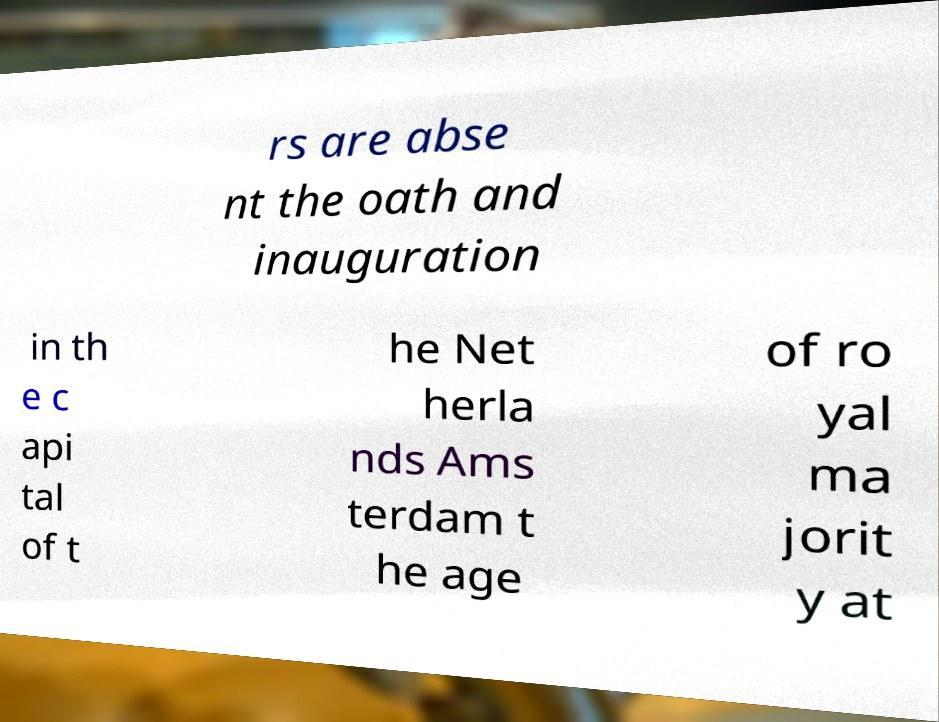Please identify and transcribe the text found in this image. rs are abse nt the oath and inauguration in th e c api tal of t he Net herla nds Ams terdam t he age of ro yal ma jorit y at 